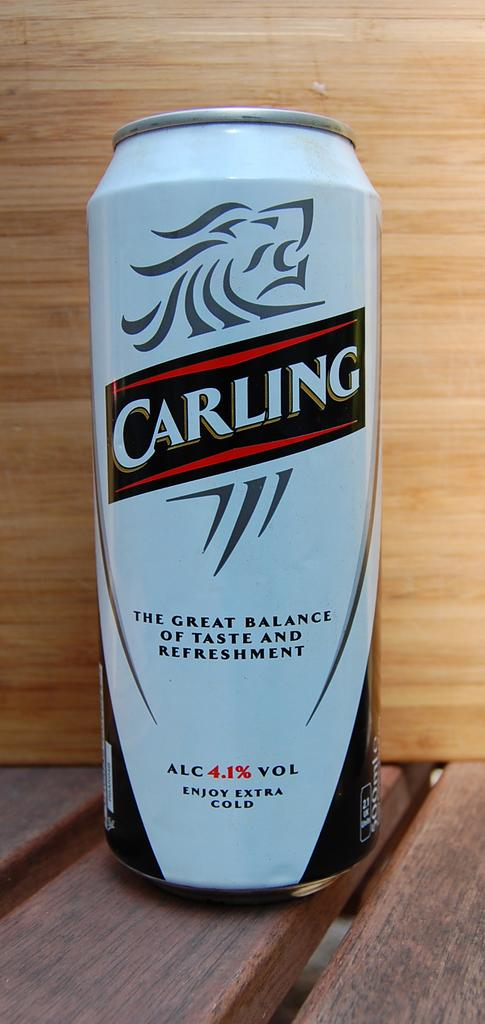<image>
Give a short and clear explanation of the subsequent image. a can of carling with 4.1% alcohol by volume 